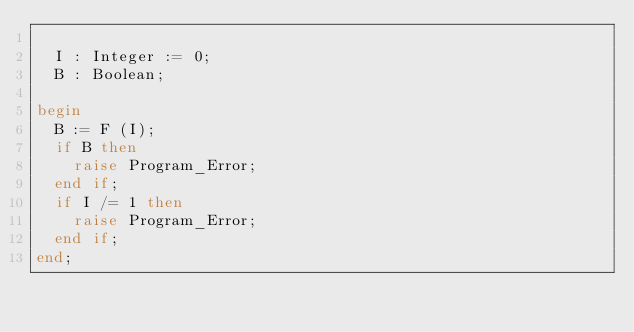<code> <loc_0><loc_0><loc_500><loc_500><_Ada_>
  I : Integer := 0;
  B : Boolean;

begin
  B := F (I);
  if B then
    raise Program_Error;
  end if;
  if I /= 1 then
    raise Program_Error;
  end if;
end;
</code> 